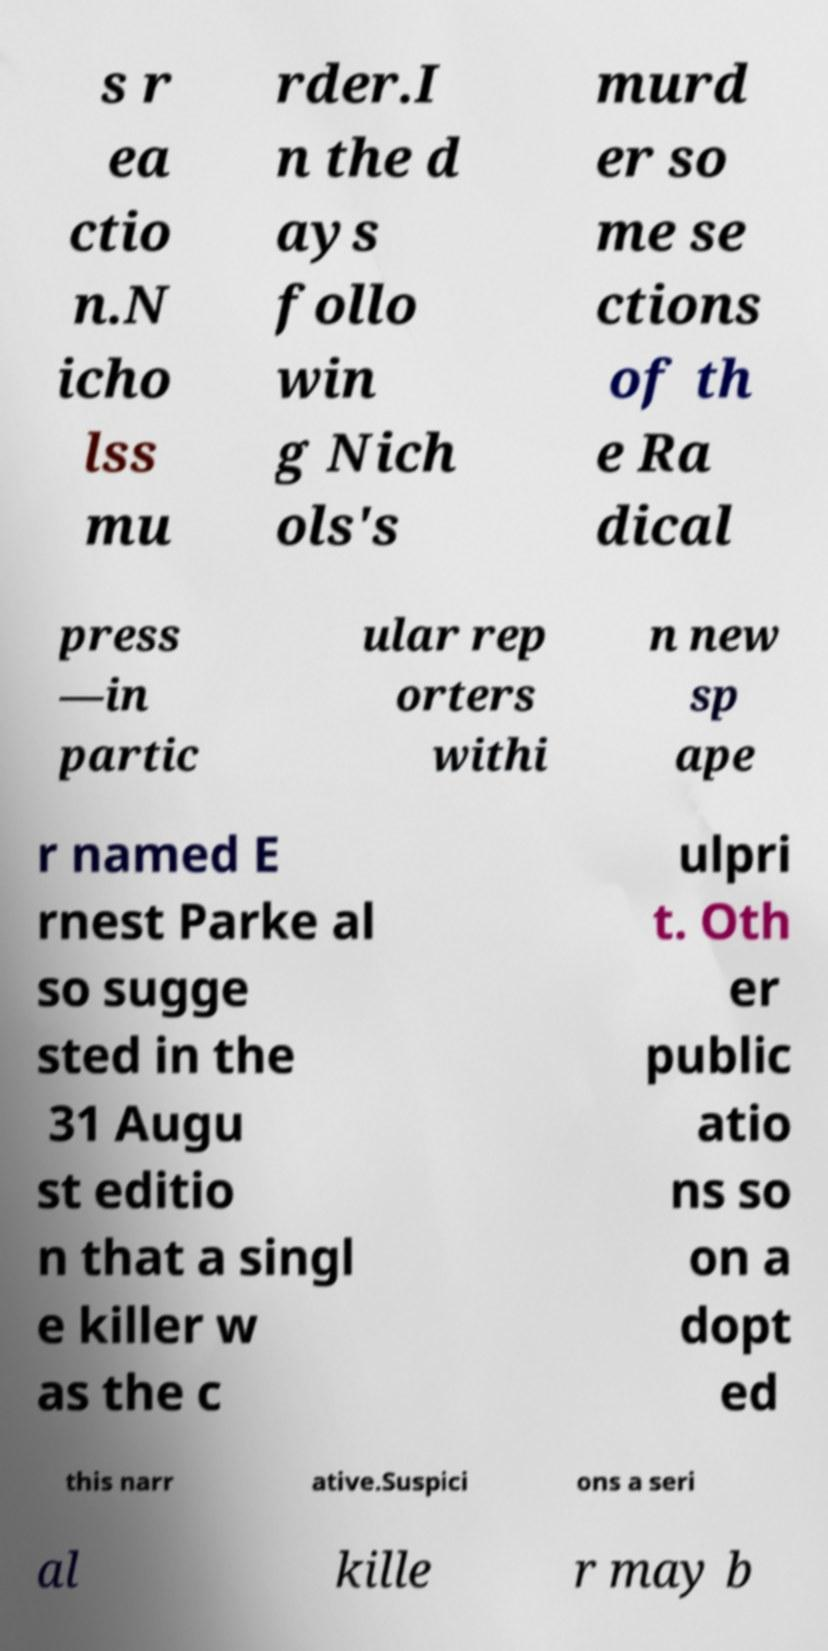Please identify and transcribe the text found in this image. s r ea ctio n.N icho lss mu rder.I n the d ays follo win g Nich ols's murd er so me se ctions of th e Ra dical press —in partic ular rep orters withi n new sp ape r named E rnest Parke al so sugge sted in the 31 Augu st editio n that a singl e killer w as the c ulpri t. Oth er public atio ns so on a dopt ed this narr ative.Suspici ons a seri al kille r may b 